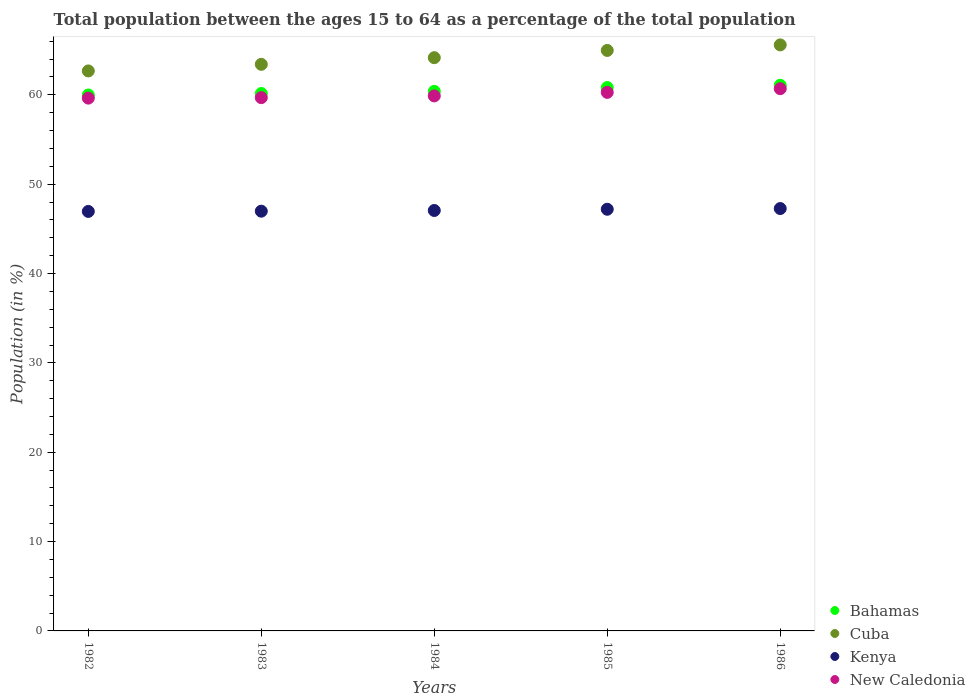How many different coloured dotlines are there?
Ensure brevity in your answer.  4. What is the percentage of the population ages 15 to 64 in Cuba in 1985?
Keep it short and to the point. 64.97. Across all years, what is the maximum percentage of the population ages 15 to 64 in Bahamas?
Give a very brief answer. 61.07. Across all years, what is the minimum percentage of the population ages 15 to 64 in Kenya?
Give a very brief answer. 46.95. In which year was the percentage of the population ages 15 to 64 in Bahamas maximum?
Provide a succinct answer. 1986. In which year was the percentage of the population ages 15 to 64 in Cuba minimum?
Provide a short and direct response. 1982. What is the total percentage of the population ages 15 to 64 in Kenya in the graph?
Provide a succinct answer. 235.46. What is the difference between the percentage of the population ages 15 to 64 in Bahamas in 1985 and that in 1986?
Make the answer very short. -0.26. What is the difference between the percentage of the population ages 15 to 64 in Cuba in 1985 and the percentage of the population ages 15 to 64 in Kenya in 1982?
Offer a very short reply. 18.02. What is the average percentage of the population ages 15 to 64 in Kenya per year?
Your response must be concise. 47.09. In the year 1985, what is the difference between the percentage of the population ages 15 to 64 in Kenya and percentage of the population ages 15 to 64 in Bahamas?
Your answer should be very brief. -13.62. In how many years, is the percentage of the population ages 15 to 64 in New Caledonia greater than 44?
Offer a terse response. 5. What is the ratio of the percentage of the population ages 15 to 64 in Kenya in 1983 to that in 1985?
Keep it short and to the point. 1. What is the difference between the highest and the second highest percentage of the population ages 15 to 64 in New Caledonia?
Your response must be concise. 0.41. What is the difference between the highest and the lowest percentage of the population ages 15 to 64 in New Caledonia?
Provide a succinct answer. 1.05. In how many years, is the percentage of the population ages 15 to 64 in New Caledonia greater than the average percentage of the population ages 15 to 64 in New Caledonia taken over all years?
Offer a terse response. 2. Is the sum of the percentage of the population ages 15 to 64 in Bahamas in 1983 and 1986 greater than the maximum percentage of the population ages 15 to 64 in Kenya across all years?
Offer a very short reply. Yes. Does the percentage of the population ages 15 to 64 in Bahamas monotonically increase over the years?
Provide a short and direct response. Yes. Is the percentage of the population ages 15 to 64 in Bahamas strictly greater than the percentage of the population ages 15 to 64 in New Caledonia over the years?
Your answer should be very brief. Yes. Does the graph contain any zero values?
Offer a terse response. No. Where does the legend appear in the graph?
Your answer should be very brief. Bottom right. How are the legend labels stacked?
Your response must be concise. Vertical. What is the title of the graph?
Your response must be concise. Total population between the ages 15 to 64 as a percentage of the total population. What is the label or title of the X-axis?
Make the answer very short. Years. What is the label or title of the Y-axis?
Your response must be concise. Population (in %). What is the Population (in %) in Bahamas in 1982?
Offer a terse response. 59.98. What is the Population (in %) of Cuba in 1982?
Provide a succinct answer. 62.68. What is the Population (in %) in Kenya in 1982?
Give a very brief answer. 46.95. What is the Population (in %) of New Caledonia in 1982?
Your answer should be compact. 59.63. What is the Population (in %) in Bahamas in 1983?
Offer a terse response. 60.15. What is the Population (in %) in Cuba in 1983?
Make the answer very short. 63.42. What is the Population (in %) of Kenya in 1983?
Your answer should be compact. 46.98. What is the Population (in %) of New Caledonia in 1983?
Make the answer very short. 59.69. What is the Population (in %) of Bahamas in 1984?
Provide a short and direct response. 60.39. What is the Population (in %) of Cuba in 1984?
Offer a very short reply. 64.16. What is the Population (in %) of Kenya in 1984?
Your answer should be compact. 47.06. What is the Population (in %) of New Caledonia in 1984?
Offer a very short reply. 59.88. What is the Population (in %) in Bahamas in 1985?
Provide a succinct answer. 60.81. What is the Population (in %) of Cuba in 1985?
Your answer should be very brief. 64.97. What is the Population (in %) of Kenya in 1985?
Keep it short and to the point. 47.19. What is the Population (in %) of New Caledonia in 1985?
Offer a very short reply. 60.28. What is the Population (in %) of Bahamas in 1986?
Make the answer very short. 61.07. What is the Population (in %) in Cuba in 1986?
Make the answer very short. 65.59. What is the Population (in %) of Kenya in 1986?
Keep it short and to the point. 47.27. What is the Population (in %) of New Caledonia in 1986?
Keep it short and to the point. 60.69. Across all years, what is the maximum Population (in %) of Bahamas?
Make the answer very short. 61.07. Across all years, what is the maximum Population (in %) in Cuba?
Keep it short and to the point. 65.59. Across all years, what is the maximum Population (in %) in Kenya?
Your response must be concise. 47.27. Across all years, what is the maximum Population (in %) in New Caledonia?
Make the answer very short. 60.69. Across all years, what is the minimum Population (in %) in Bahamas?
Offer a terse response. 59.98. Across all years, what is the minimum Population (in %) in Cuba?
Make the answer very short. 62.68. Across all years, what is the minimum Population (in %) in Kenya?
Keep it short and to the point. 46.95. Across all years, what is the minimum Population (in %) of New Caledonia?
Ensure brevity in your answer.  59.63. What is the total Population (in %) of Bahamas in the graph?
Your response must be concise. 302.4. What is the total Population (in %) of Cuba in the graph?
Keep it short and to the point. 320.81. What is the total Population (in %) in Kenya in the graph?
Provide a succinct answer. 235.46. What is the total Population (in %) of New Caledonia in the graph?
Give a very brief answer. 300.17. What is the difference between the Population (in %) in Bahamas in 1982 and that in 1983?
Offer a very short reply. -0.17. What is the difference between the Population (in %) in Cuba in 1982 and that in 1983?
Give a very brief answer. -0.74. What is the difference between the Population (in %) of Kenya in 1982 and that in 1983?
Make the answer very short. -0.03. What is the difference between the Population (in %) in New Caledonia in 1982 and that in 1983?
Provide a succinct answer. -0.05. What is the difference between the Population (in %) in Bahamas in 1982 and that in 1984?
Your response must be concise. -0.4. What is the difference between the Population (in %) in Cuba in 1982 and that in 1984?
Your response must be concise. -1.48. What is the difference between the Population (in %) in Kenya in 1982 and that in 1984?
Offer a terse response. -0.11. What is the difference between the Population (in %) in New Caledonia in 1982 and that in 1984?
Offer a very short reply. -0.25. What is the difference between the Population (in %) of Bahamas in 1982 and that in 1985?
Offer a terse response. -0.83. What is the difference between the Population (in %) of Cuba in 1982 and that in 1985?
Offer a terse response. -2.3. What is the difference between the Population (in %) in Kenya in 1982 and that in 1985?
Your response must be concise. -0.24. What is the difference between the Population (in %) in New Caledonia in 1982 and that in 1985?
Your answer should be compact. -0.64. What is the difference between the Population (in %) of Bahamas in 1982 and that in 1986?
Ensure brevity in your answer.  -1.09. What is the difference between the Population (in %) in Cuba in 1982 and that in 1986?
Provide a succinct answer. -2.91. What is the difference between the Population (in %) in Kenya in 1982 and that in 1986?
Make the answer very short. -0.32. What is the difference between the Population (in %) of New Caledonia in 1982 and that in 1986?
Offer a terse response. -1.05. What is the difference between the Population (in %) in Bahamas in 1983 and that in 1984?
Your response must be concise. -0.24. What is the difference between the Population (in %) in Cuba in 1983 and that in 1984?
Your answer should be very brief. -0.74. What is the difference between the Population (in %) in Kenya in 1983 and that in 1984?
Give a very brief answer. -0.08. What is the difference between the Population (in %) of New Caledonia in 1983 and that in 1984?
Provide a succinct answer. -0.19. What is the difference between the Population (in %) in Bahamas in 1983 and that in 1985?
Your answer should be compact. -0.66. What is the difference between the Population (in %) in Cuba in 1983 and that in 1985?
Give a very brief answer. -1.56. What is the difference between the Population (in %) in Kenya in 1983 and that in 1985?
Make the answer very short. -0.22. What is the difference between the Population (in %) in New Caledonia in 1983 and that in 1985?
Your answer should be compact. -0.59. What is the difference between the Population (in %) of Bahamas in 1983 and that in 1986?
Provide a short and direct response. -0.92. What is the difference between the Population (in %) of Cuba in 1983 and that in 1986?
Make the answer very short. -2.17. What is the difference between the Population (in %) of Kenya in 1983 and that in 1986?
Provide a succinct answer. -0.29. What is the difference between the Population (in %) of New Caledonia in 1983 and that in 1986?
Ensure brevity in your answer.  -1. What is the difference between the Population (in %) in Bahamas in 1984 and that in 1985?
Offer a terse response. -0.43. What is the difference between the Population (in %) of Cuba in 1984 and that in 1985?
Your answer should be compact. -0.81. What is the difference between the Population (in %) of Kenya in 1984 and that in 1985?
Your answer should be compact. -0.14. What is the difference between the Population (in %) in New Caledonia in 1984 and that in 1985?
Provide a succinct answer. -0.39. What is the difference between the Population (in %) of Bahamas in 1984 and that in 1986?
Offer a very short reply. -0.68. What is the difference between the Population (in %) of Cuba in 1984 and that in 1986?
Your answer should be compact. -1.43. What is the difference between the Population (in %) of Kenya in 1984 and that in 1986?
Offer a very short reply. -0.22. What is the difference between the Population (in %) in New Caledonia in 1984 and that in 1986?
Keep it short and to the point. -0.81. What is the difference between the Population (in %) of Bahamas in 1985 and that in 1986?
Your answer should be compact. -0.26. What is the difference between the Population (in %) of Cuba in 1985 and that in 1986?
Keep it short and to the point. -0.62. What is the difference between the Population (in %) of Kenya in 1985 and that in 1986?
Your response must be concise. -0.08. What is the difference between the Population (in %) of New Caledonia in 1985 and that in 1986?
Ensure brevity in your answer.  -0.41. What is the difference between the Population (in %) of Bahamas in 1982 and the Population (in %) of Cuba in 1983?
Offer a terse response. -3.43. What is the difference between the Population (in %) in Bahamas in 1982 and the Population (in %) in Kenya in 1983?
Offer a terse response. 13. What is the difference between the Population (in %) in Bahamas in 1982 and the Population (in %) in New Caledonia in 1983?
Ensure brevity in your answer.  0.3. What is the difference between the Population (in %) in Cuba in 1982 and the Population (in %) in Kenya in 1983?
Provide a short and direct response. 15.7. What is the difference between the Population (in %) in Cuba in 1982 and the Population (in %) in New Caledonia in 1983?
Your response must be concise. 2.99. What is the difference between the Population (in %) of Kenya in 1982 and the Population (in %) of New Caledonia in 1983?
Your response must be concise. -12.74. What is the difference between the Population (in %) in Bahamas in 1982 and the Population (in %) in Cuba in 1984?
Your response must be concise. -4.18. What is the difference between the Population (in %) in Bahamas in 1982 and the Population (in %) in Kenya in 1984?
Provide a succinct answer. 12.93. What is the difference between the Population (in %) in Bahamas in 1982 and the Population (in %) in New Caledonia in 1984?
Provide a succinct answer. 0.1. What is the difference between the Population (in %) in Cuba in 1982 and the Population (in %) in Kenya in 1984?
Provide a succinct answer. 15.62. What is the difference between the Population (in %) of Cuba in 1982 and the Population (in %) of New Caledonia in 1984?
Provide a short and direct response. 2.79. What is the difference between the Population (in %) of Kenya in 1982 and the Population (in %) of New Caledonia in 1984?
Offer a terse response. -12.93. What is the difference between the Population (in %) in Bahamas in 1982 and the Population (in %) in Cuba in 1985?
Offer a very short reply. -4.99. What is the difference between the Population (in %) of Bahamas in 1982 and the Population (in %) of Kenya in 1985?
Provide a short and direct response. 12.79. What is the difference between the Population (in %) in Bahamas in 1982 and the Population (in %) in New Caledonia in 1985?
Provide a succinct answer. -0.29. What is the difference between the Population (in %) of Cuba in 1982 and the Population (in %) of Kenya in 1985?
Offer a very short reply. 15.48. What is the difference between the Population (in %) of Cuba in 1982 and the Population (in %) of New Caledonia in 1985?
Make the answer very short. 2.4. What is the difference between the Population (in %) in Kenya in 1982 and the Population (in %) in New Caledonia in 1985?
Give a very brief answer. -13.32. What is the difference between the Population (in %) of Bahamas in 1982 and the Population (in %) of Cuba in 1986?
Provide a succinct answer. -5.61. What is the difference between the Population (in %) of Bahamas in 1982 and the Population (in %) of Kenya in 1986?
Give a very brief answer. 12.71. What is the difference between the Population (in %) in Bahamas in 1982 and the Population (in %) in New Caledonia in 1986?
Keep it short and to the point. -0.71. What is the difference between the Population (in %) of Cuba in 1982 and the Population (in %) of Kenya in 1986?
Your response must be concise. 15.4. What is the difference between the Population (in %) in Cuba in 1982 and the Population (in %) in New Caledonia in 1986?
Keep it short and to the point. 1.99. What is the difference between the Population (in %) in Kenya in 1982 and the Population (in %) in New Caledonia in 1986?
Give a very brief answer. -13.74. What is the difference between the Population (in %) in Bahamas in 1983 and the Population (in %) in Cuba in 1984?
Offer a very short reply. -4.01. What is the difference between the Population (in %) in Bahamas in 1983 and the Population (in %) in Kenya in 1984?
Make the answer very short. 13.09. What is the difference between the Population (in %) of Bahamas in 1983 and the Population (in %) of New Caledonia in 1984?
Your answer should be compact. 0.27. What is the difference between the Population (in %) of Cuba in 1983 and the Population (in %) of Kenya in 1984?
Offer a very short reply. 16.36. What is the difference between the Population (in %) of Cuba in 1983 and the Population (in %) of New Caledonia in 1984?
Offer a terse response. 3.53. What is the difference between the Population (in %) of Kenya in 1983 and the Population (in %) of New Caledonia in 1984?
Your answer should be compact. -12.9. What is the difference between the Population (in %) of Bahamas in 1983 and the Population (in %) of Cuba in 1985?
Make the answer very short. -4.82. What is the difference between the Population (in %) of Bahamas in 1983 and the Population (in %) of Kenya in 1985?
Ensure brevity in your answer.  12.95. What is the difference between the Population (in %) in Bahamas in 1983 and the Population (in %) in New Caledonia in 1985?
Provide a succinct answer. -0.13. What is the difference between the Population (in %) in Cuba in 1983 and the Population (in %) in Kenya in 1985?
Your answer should be very brief. 16.22. What is the difference between the Population (in %) of Cuba in 1983 and the Population (in %) of New Caledonia in 1985?
Make the answer very short. 3.14. What is the difference between the Population (in %) of Kenya in 1983 and the Population (in %) of New Caledonia in 1985?
Provide a succinct answer. -13.3. What is the difference between the Population (in %) in Bahamas in 1983 and the Population (in %) in Cuba in 1986?
Your answer should be very brief. -5.44. What is the difference between the Population (in %) in Bahamas in 1983 and the Population (in %) in Kenya in 1986?
Your answer should be very brief. 12.88. What is the difference between the Population (in %) of Bahamas in 1983 and the Population (in %) of New Caledonia in 1986?
Ensure brevity in your answer.  -0.54. What is the difference between the Population (in %) in Cuba in 1983 and the Population (in %) in Kenya in 1986?
Offer a very short reply. 16.14. What is the difference between the Population (in %) in Cuba in 1983 and the Population (in %) in New Caledonia in 1986?
Your answer should be very brief. 2.73. What is the difference between the Population (in %) of Kenya in 1983 and the Population (in %) of New Caledonia in 1986?
Your answer should be compact. -13.71. What is the difference between the Population (in %) of Bahamas in 1984 and the Population (in %) of Cuba in 1985?
Provide a succinct answer. -4.58. What is the difference between the Population (in %) in Bahamas in 1984 and the Population (in %) in Kenya in 1985?
Offer a terse response. 13.19. What is the difference between the Population (in %) of Bahamas in 1984 and the Population (in %) of New Caledonia in 1985?
Provide a short and direct response. 0.11. What is the difference between the Population (in %) of Cuba in 1984 and the Population (in %) of Kenya in 1985?
Your response must be concise. 16.96. What is the difference between the Population (in %) of Cuba in 1984 and the Population (in %) of New Caledonia in 1985?
Keep it short and to the point. 3.88. What is the difference between the Population (in %) of Kenya in 1984 and the Population (in %) of New Caledonia in 1985?
Provide a short and direct response. -13.22. What is the difference between the Population (in %) in Bahamas in 1984 and the Population (in %) in Cuba in 1986?
Your answer should be compact. -5.2. What is the difference between the Population (in %) of Bahamas in 1984 and the Population (in %) of Kenya in 1986?
Make the answer very short. 13.11. What is the difference between the Population (in %) in Bahamas in 1984 and the Population (in %) in New Caledonia in 1986?
Give a very brief answer. -0.3. What is the difference between the Population (in %) in Cuba in 1984 and the Population (in %) in Kenya in 1986?
Ensure brevity in your answer.  16.89. What is the difference between the Population (in %) in Cuba in 1984 and the Population (in %) in New Caledonia in 1986?
Make the answer very short. 3.47. What is the difference between the Population (in %) in Kenya in 1984 and the Population (in %) in New Caledonia in 1986?
Make the answer very short. -13.63. What is the difference between the Population (in %) in Bahamas in 1985 and the Population (in %) in Cuba in 1986?
Your answer should be compact. -4.78. What is the difference between the Population (in %) of Bahamas in 1985 and the Population (in %) of Kenya in 1986?
Your answer should be very brief. 13.54. What is the difference between the Population (in %) of Bahamas in 1985 and the Population (in %) of New Caledonia in 1986?
Keep it short and to the point. 0.13. What is the difference between the Population (in %) in Cuba in 1985 and the Population (in %) in Kenya in 1986?
Your answer should be very brief. 17.7. What is the difference between the Population (in %) of Cuba in 1985 and the Population (in %) of New Caledonia in 1986?
Your answer should be compact. 4.28. What is the difference between the Population (in %) in Kenya in 1985 and the Population (in %) in New Caledonia in 1986?
Make the answer very short. -13.49. What is the average Population (in %) in Bahamas per year?
Your answer should be very brief. 60.48. What is the average Population (in %) of Cuba per year?
Your answer should be compact. 64.16. What is the average Population (in %) in Kenya per year?
Ensure brevity in your answer.  47.09. What is the average Population (in %) in New Caledonia per year?
Make the answer very short. 60.03. In the year 1982, what is the difference between the Population (in %) of Bahamas and Population (in %) of Cuba?
Provide a succinct answer. -2.69. In the year 1982, what is the difference between the Population (in %) in Bahamas and Population (in %) in Kenya?
Keep it short and to the point. 13.03. In the year 1982, what is the difference between the Population (in %) in Bahamas and Population (in %) in New Caledonia?
Provide a succinct answer. 0.35. In the year 1982, what is the difference between the Population (in %) of Cuba and Population (in %) of Kenya?
Provide a short and direct response. 15.72. In the year 1982, what is the difference between the Population (in %) in Cuba and Population (in %) in New Caledonia?
Provide a short and direct response. 3.04. In the year 1982, what is the difference between the Population (in %) of Kenya and Population (in %) of New Caledonia?
Provide a short and direct response. -12.68. In the year 1983, what is the difference between the Population (in %) in Bahamas and Population (in %) in Cuba?
Provide a short and direct response. -3.27. In the year 1983, what is the difference between the Population (in %) in Bahamas and Population (in %) in Kenya?
Your answer should be compact. 13.17. In the year 1983, what is the difference between the Population (in %) of Bahamas and Population (in %) of New Caledonia?
Offer a terse response. 0.46. In the year 1983, what is the difference between the Population (in %) in Cuba and Population (in %) in Kenya?
Offer a terse response. 16.44. In the year 1983, what is the difference between the Population (in %) in Cuba and Population (in %) in New Caledonia?
Offer a terse response. 3.73. In the year 1983, what is the difference between the Population (in %) in Kenya and Population (in %) in New Caledonia?
Your answer should be compact. -12.71. In the year 1984, what is the difference between the Population (in %) of Bahamas and Population (in %) of Cuba?
Your response must be concise. -3.77. In the year 1984, what is the difference between the Population (in %) of Bahamas and Population (in %) of Kenya?
Your answer should be compact. 13.33. In the year 1984, what is the difference between the Population (in %) in Bahamas and Population (in %) in New Caledonia?
Make the answer very short. 0.51. In the year 1984, what is the difference between the Population (in %) in Cuba and Population (in %) in Kenya?
Provide a short and direct response. 17.1. In the year 1984, what is the difference between the Population (in %) in Cuba and Population (in %) in New Caledonia?
Offer a terse response. 4.28. In the year 1984, what is the difference between the Population (in %) in Kenya and Population (in %) in New Caledonia?
Give a very brief answer. -12.82. In the year 1985, what is the difference between the Population (in %) of Bahamas and Population (in %) of Cuba?
Ensure brevity in your answer.  -4.16. In the year 1985, what is the difference between the Population (in %) in Bahamas and Population (in %) in Kenya?
Offer a very short reply. 13.62. In the year 1985, what is the difference between the Population (in %) of Bahamas and Population (in %) of New Caledonia?
Offer a terse response. 0.54. In the year 1985, what is the difference between the Population (in %) of Cuba and Population (in %) of Kenya?
Keep it short and to the point. 17.78. In the year 1985, what is the difference between the Population (in %) of Cuba and Population (in %) of New Caledonia?
Provide a short and direct response. 4.69. In the year 1985, what is the difference between the Population (in %) of Kenya and Population (in %) of New Caledonia?
Offer a terse response. -13.08. In the year 1986, what is the difference between the Population (in %) of Bahamas and Population (in %) of Cuba?
Ensure brevity in your answer.  -4.52. In the year 1986, what is the difference between the Population (in %) in Bahamas and Population (in %) in Kenya?
Your response must be concise. 13.8. In the year 1986, what is the difference between the Population (in %) of Bahamas and Population (in %) of New Caledonia?
Make the answer very short. 0.38. In the year 1986, what is the difference between the Population (in %) of Cuba and Population (in %) of Kenya?
Your answer should be very brief. 18.32. In the year 1986, what is the difference between the Population (in %) of Cuba and Population (in %) of New Caledonia?
Make the answer very short. 4.9. In the year 1986, what is the difference between the Population (in %) in Kenya and Population (in %) in New Caledonia?
Ensure brevity in your answer.  -13.42. What is the ratio of the Population (in %) of Bahamas in 1982 to that in 1983?
Offer a very short reply. 1. What is the ratio of the Population (in %) in Cuba in 1982 to that in 1983?
Ensure brevity in your answer.  0.99. What is the ratio of the Population (in %) in Kenya in 1982 to that in 1983?
Your answer should be very brief. 1. What is the ratio of the Population (in %) in Bahamas in 1982 to that in 1984?
Offer a terse response. 0.99. What is the ratio of the Population (in %) in Cuba in 1982 to that in 1984?
Ensure brevity in your answer.  0.98. What is the ratio of the Population (in %) in Bahamas in 1982 to that in 1985?
Offer a very short reply. 0.99. What is the ratio of the Population (in %) of Cuba in 1982 to that in 1985?
Provide a short and direct response. 0.96. What is the ratio of the Population (in %) of Kenya in 1982 to that in 1985?
Provide a short and direct response. 0.99. What is the ratio of the Population (in %) of New Caledonia in 1982 to that in 1985?
Provide a short and direct response. 0.99. What is the ratio of the Population (in %) in Bahamas in 1982 to that in 1986?
Provide a succinct answer. 0.98. What is the ratio of the Population (in %) in Cuba in 1982 to that in 1986?
Offer a terse response. 0.96. What is the ratio of the Population (in %) in Kenya in 1982 to that in 1986?
Make the answer very short. 0.99. What is the ratio of the Population (in %) of New Caledonia in 1982 to that in 1986?
Offer a terse response. 0.98. What is the ratio of the Population (in %) of Bahamas in 1983 to that in 1984?
Offer a terse response. 1. What is the ratio of the Population (in %) of Cuba in 1983 to that in 1984?
Keep it short and to the point. 0.99. What is the ratio of the Population (in %) of New Caledonia in 1983 to that in 1984?
Offer a very short reply. 1. What is the ratio of the Population (in %) of Cuba in 1983 to that in 1985?
Your answer should be compact. 0.98. What is the ratio of the Population (in %) of New Caledonia in 1983 to that in 1985?
Your answer should be compact. 0.99. What is the ratio of the Population (in %) of Bahamas in 1983 to that in 1986?
Offer a terse response. 0.98. What is the ratio of the Population (in %) in Cuba in 1983 to that in 1986?
Provide a short and direct response. 0.97. What is the ratio of the Population (in %) in New Caledonia in 1983 to that in 1986?
Offer a very short reply. 0.98. What is the ratio of the Population (in %) of Cuba in 1984 to that in 1985?
Your answer should be compact. 0.99. What is the ratio of the Population (in %) in Kenya in 1984 to that in 1985?
Provide a succinct answer. 1. What is the ratio of the Population (in %) in New Caledonia in 1984 to that in 1985?
Offer a terse response. 0.99. What is the ratio of the Population (in %) of Bahamas in 1984 to that in 1986?
Give a very brief answer. 0.99. What is the ratio of the Population (in %) of Cuba in 1984 to that in 1986?
Provide a short and direct response. 0.98. What is the ratio of the Population (in %) in Kenya in 1984 to that in 1986?
Offer a terse response. 1. What is the ratio of the Population (in %) in New Caledonia in 1984 to that in 1986?
Offer a terse response. 0.99. What is the ratio of the Population (in %) in Cuba in 1985 to that in 1986?
Ensure brevity in your answer.  0.99. What is the ratio of the Population (in %) of New Caledonia in 1985 to that in 1986?
Your answer should be very brief. 0.99. What is the difference between the highest and the second highest Population (in %) of Bahamas?
Provide a short and direct response. 0.26. What is the difference between the highest and the second highest Population (in %) in Cuba?
Keep it short and to the point. 0.62. What is the difference between the highest and the second highest Population (in %) in Kenya?
Provide a short and direct response. 0.08. What is the difference between the highest and the second highest Population (in %) of New Caledonia?
Your answer should be compact. 0.41. What is the difference between the highest and the lowest Population (in %) in Bahamas?
Your response must be concise. 1.09. What is the difference between the highest and the lowest Population (in %) in Cuba?
Your answer should be compact. 2.91. What is the difference between the highest and the lowest Population (in %) in Kenya?
Make the answer very short. 0.32. What is the difference between the highest and the lowest Population (in %) in New Caledonia?
Your answer should be compact. 1.05. 